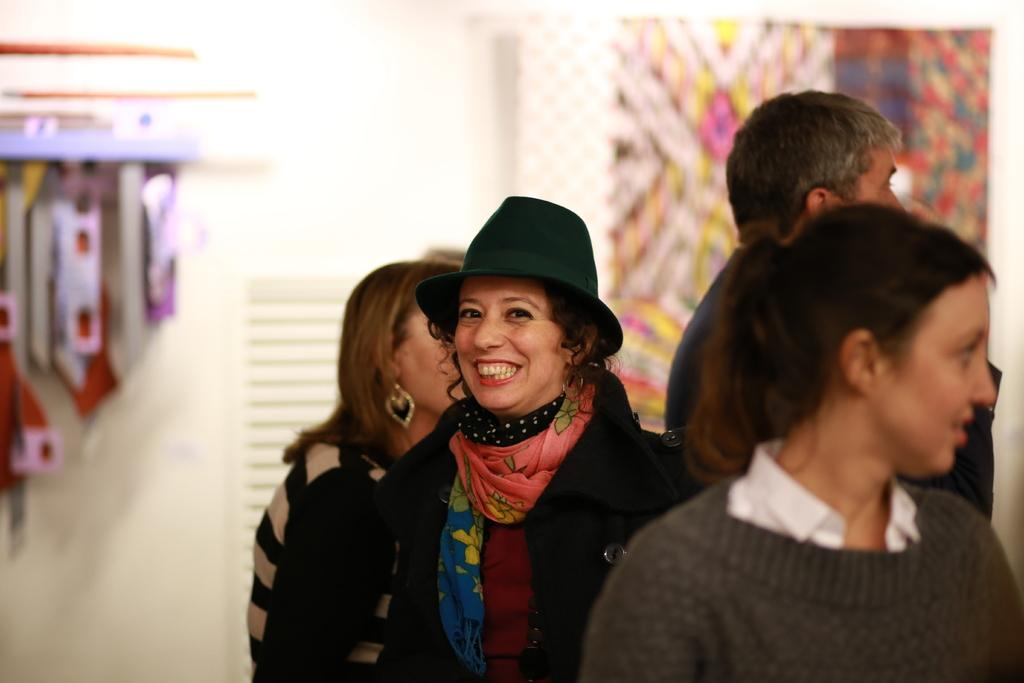How many people are in the image? There is a group of people in the image. Can you describe the person in the front? The person in front is wearing a black jacket, a maroon shirt, and an orange and blue color scarf. What is the color of the wall in the background of the image? There is a white wall in the background of the image. What type of linen is draped over the tiger in the image? There is no tiger or linen present in the image. How does the jelly interact with the person in the front? There is no jelly present in the image, so it cannot interact with the person in the front. 